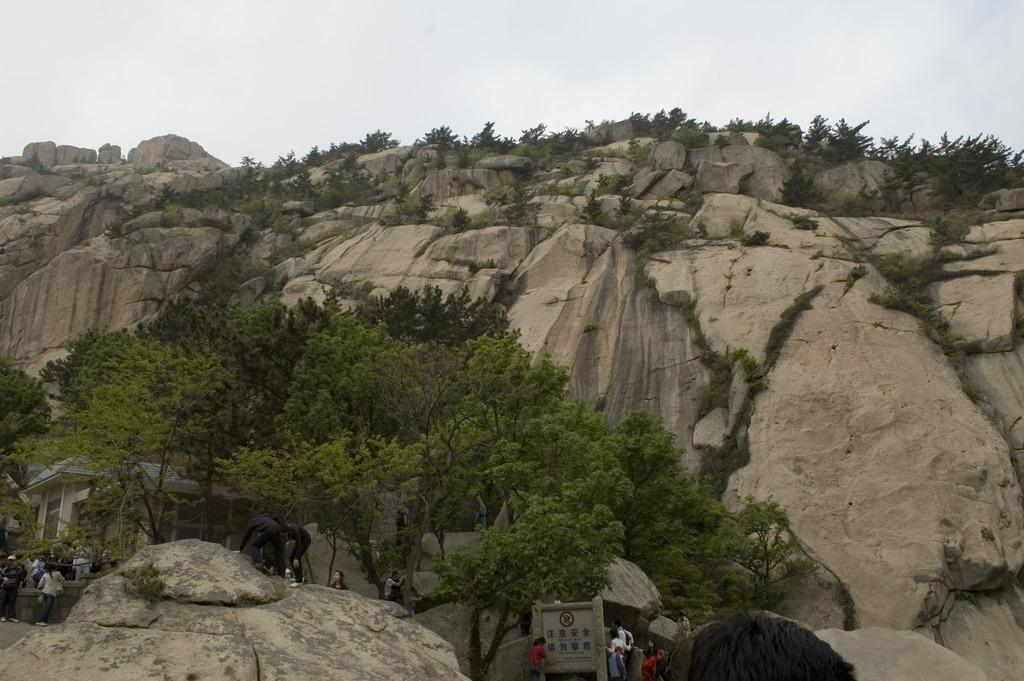What is the main geographical feature in the image? There is a mountain in the image. What can be seen under the mountain? There are trees, a house, people, and an elephant under the mountain. Can you describe the vegetation under the mountain? There are trees under the mountain. What type of structure is located under the mountain? There is a house under the mountain. How does the snail compare to the mountain in size in the image? There is no snail present in the image, so it cannot be compared to the mountain in size. Is there any popcorn visible in the image? There is no popcorn present in the image. 